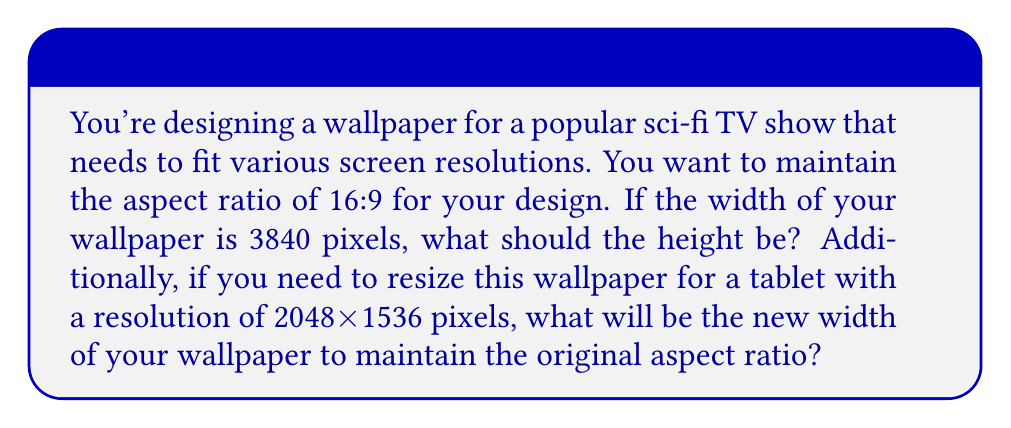Teach me how to tackle this problem. Let's approach this problem step by step:

1. Calculate the height for the 16:9 aspect ratio:
   - The aspect ratio is given as width:height = 16:9
   - We can set up the equation: $\frac{\text{width}}{\text{height}} = \frac{16}{9}$
   - Given width = 3840 pixels, we have: $\frac{3840}{\text{height}} = \frac{16}{9}$
   - Cross-multiply: $9 \cdot 3840 = 16 \cdot \text{height}$
   - Solve for height: $\text{height} = \frac{9 \cdot 3840}{16} = 2160$ pixels

2. Resize for the tablet resolution:
   - The tablet resolution is 2048x1536 pixels
   - To maintain the aspect ratio, we need to fit the height within 1536 pixels
   - Set up a proportion: $\frac{3840}{2160} = \frac{\text{new width}}{1536}$
   - Cross-multiply: $3840 \cdot 1536 = 2160 \cdot \text{new width}$
   - Solve for new width: $\text{new width} = \frac{3840 \cdot 1536}{2160} = 2730.67$ pixels

3. Round the result to the nearest whole pixel:
   $\text{new width} \approx 2731$ pixels
Answer: The height of the wallpaper should be 2160 pixels for a 3840-pixel width to maintain a 16:9 aspect ratio. When resized for the tablet, the new width should be 2731 pixels to maintain the original aspect ratio within the 1536-pixel height constraint. 